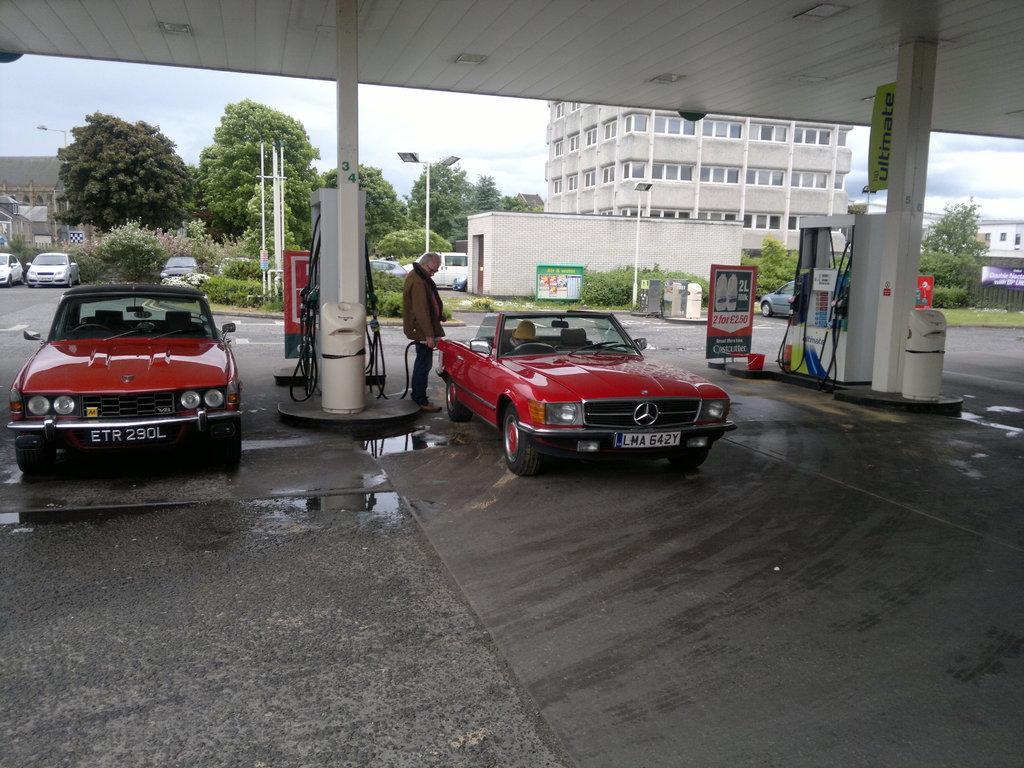Please provide a concise description of this image. In the picture there are two vehicles in a petrol bunk and behind those vehicles there are some other vehicles and in the background there are many trees and on the right side there is a building. 